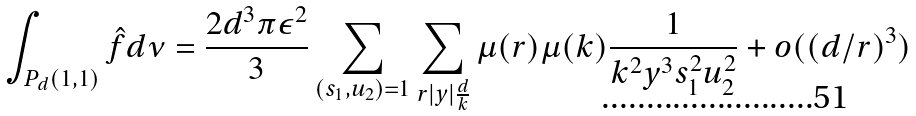Convert formula to latex. <formula><loc_0><loc_0><loc_500><loc_500>\int _ { P _ { d } ( 1 , 1 ) } \hat { f } d \nu = \frac { 2 d ^ { 3 } \pi \epsilon ^ { 2 } } { 3 } \sum _ { ( s _ { 1 } , u _ { 2 } ) = 1 } \sum _ { r | y | \frac { d } { k } } \mu ( r ) \mu ( k ) \frac { 1 } { k ^ { 2 } y ^ { 3 } s _ { 1 } ^ { 2 } u _ { 2 } ^ { 2 } } + o ( ( d / r ) ^ { 3 } )</formula> 